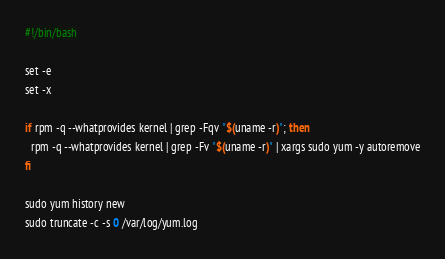Convert code to text. <code><loc_0><loc_0><loc_500><loc_500><_Bash_>#!/bin/bash

set -e
set -x

if rpm -q --whatprovides kernel | grep -Fqv "$(uname -r)"; then
  rpm -q --whatprovides kernel | grep -Fv "$(uname -r)" | xargs sudo yum -y autoremove
fi

sudo yum history new
sudo truncate -c -s 0 /var/log/yum.log
</code> 